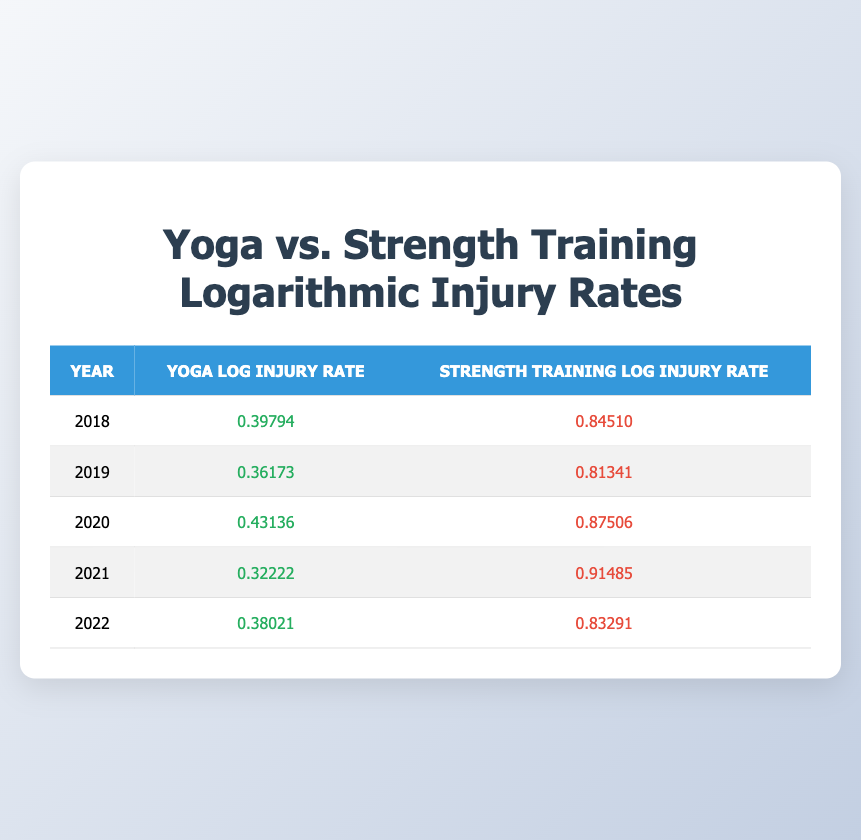What was the yoga injury rate in 2020? The table shows that the yoga injury rate per 1000 hours in 2020 is 2.7.
Answer: 2.7 What was the strength training injury rate in 2021? The table indicates that the strength training injury rate per 1000 hours in 2021 is 8.2.
Answer: 8.2 In which year did yoga have the lowest injury rate? By comparing the injury rates for yoga from the years listed, 2021 has the lowest injury rate at 2.1.
Answer: 2021 What is the average yoga injury rate across all five years? To find the average, add the injury rates: (2.5 + 2.3 + 2.7 + 2.1 + 2.4) = 12.0. Then divide by 5: 12.0 / 5 = 2.4.
Answer: 2.4 Is the strength training injury rate higher than the yoga injury rate in all years? A comparison of the rates shows that in every year listed, the strength training injury rate is indeed higher than the yoga injury rate.
Answer: Yes What was the difference in the strength training injury rate between 2018 and 2022? The strength training injury rate in 2018 is 7.0 and in 2022 is 6.8. The difference is calculated as 7.0 - 6.8 = 0.2.
Answer: 0.2 Which year showed the highest logarithmic injury rate for strength training? Looking at the logarithmic table for strength training, the highest log injury rate is 0.91485 in 2021.
Answer: 2021 What is the percentage decrease in yoga injury rates from 2018 to 2021? The injury rate in 2018 is 2.5 and in 2021 is 2.1. The decrease is 2.5 - 2.1 = 0.4. To find the percentage decrease: (0.4 / 2.5) * 100 = 16%.
Answer: 16% Is the logarithmic injury rate for yoga higher in 2020 than in 2019? The log injury rates for yoga are 0.43136 in 2020 and 0.36173 in 2019. Since 0.43136 is greater, the statement is true.
Answer: Yes 